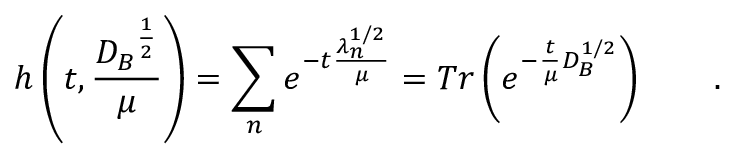Convert formula to latex. <formula><loc_0><loc_0><loc_500><loc_500>h \left ( t , \frac { { D _ { B } } ^ { \frac { 1 } { 2 } } } { \mu } \right ) = \sum _ { n } e ^ { - t \frac { \lambda _ { n } ^ { 1 / 2 } } \mu } = T r \left ( e ^ { - \frac { t } { \mu } D _ { B } ^ { 1 / 2 } } \right ) \quad .</formula> 